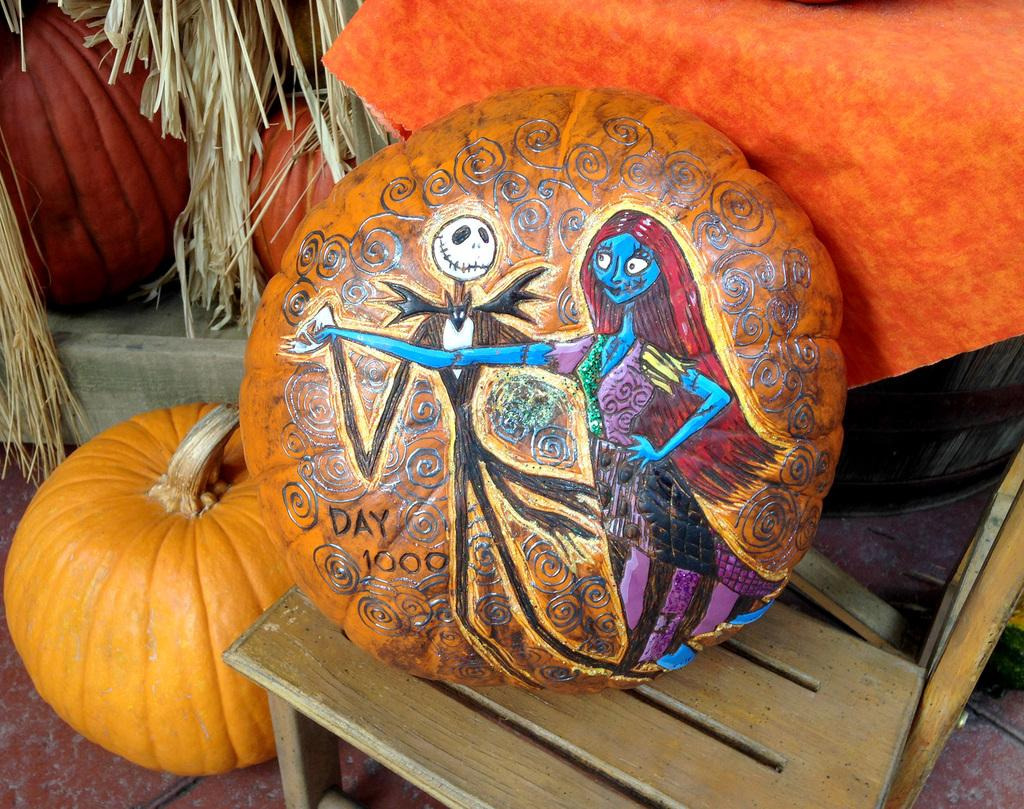What is the main subject of the image? The main subject of the image is an art design on a pumpkin. How is the pumpkin positioned in the image? The pumpkin is on a stool. What can be seen in the background of the image? There are pumpkins and a paper or thesis-like object in the background. What type of vegetation is present in the background? Dried leaves are present in the background. How much blood is visible on the pumpkin in the image? There is no blood visible on the pumpkin in the image. What type of pigs can be seen interacting with the pumpkins in the image? There are no pigs present in the image; it features an art design on a pumpkin and other elements in the background. 